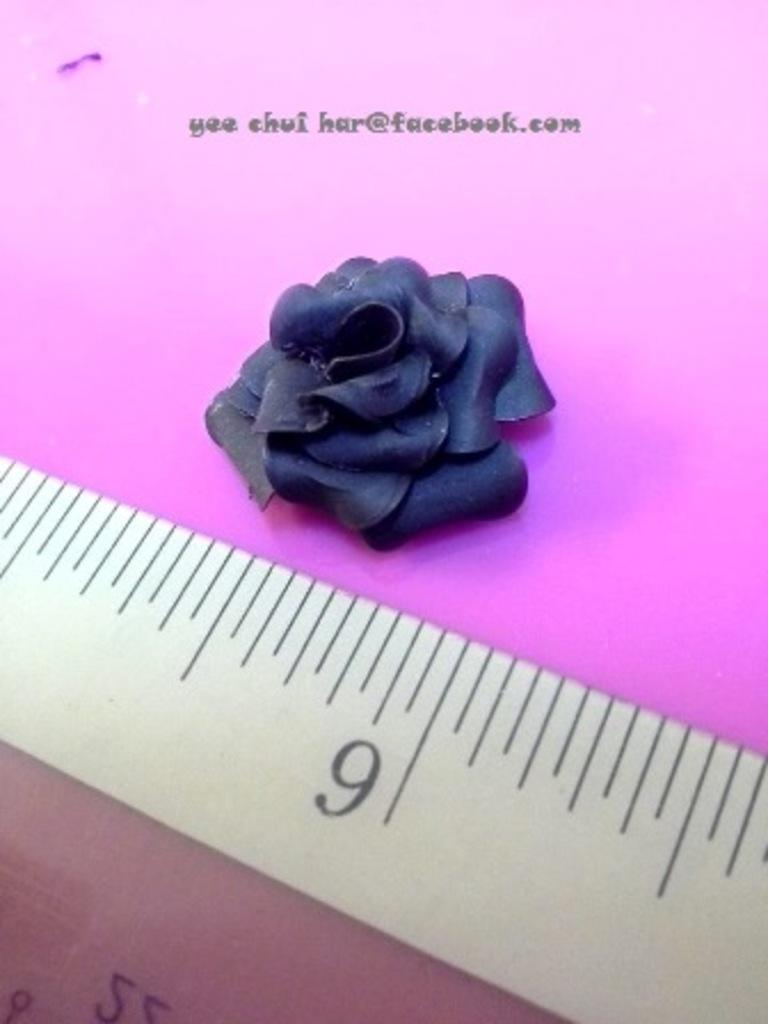<image>
Relay a brief, clear account of the picture shown. Yee chui har has a metal ruler on a pink background. 